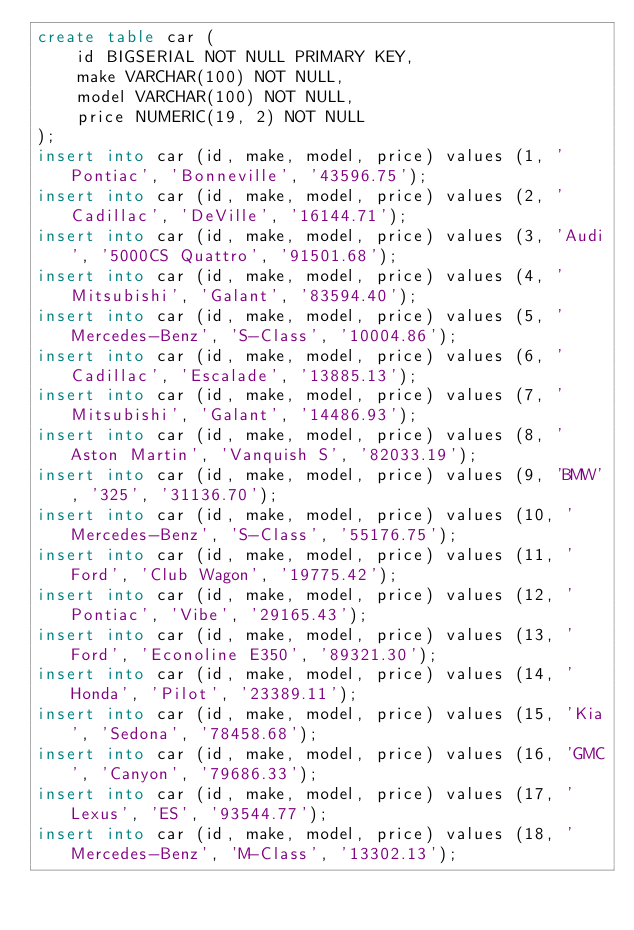Convert code to text. <code><loc_0><loc_0><loc_500><loc_500><_SQL_>create table car (
	id BIGSERIAL NOT NULL PRIMARY KEY,
	make VARCHAR(100) NOT NULL,
	model VARCHAR(100) NOT NULL,
	price NUMERIC(19, 2) NOT NULL
);
insert into car (id, make, model, price) values (1, 'Pontiac', 'Bonneville', '43596.75');
insert into car (id, make, model, price) values (2, 'Cadillac', 'DeVille', '16144.71');
insert into car (id, make, model, price) values (3, 'Audi', '5000CS Quattro', '91501.68');
insert into car (id, make, model, price) values (4, 'Mitsubishi', 'Galant', '83594.40');
insert into car (id, make, model, price) values (5, 'Mercedes-Benz', 'S-Class', '10004.86');
insert into car (id, make, model, price) values (6, 'Cadillac', 'Escalade', '13885.13');
insert into car (id, make, model, price) values (7, 'Mitsubishi', 'Galant', '14486.93');
insert into car (id, make, model, price) values (8, 'Aston Martin', 'Vanquish S', '82033.19');
insert into car (id, make, model, price) values (9, 'BMW', '325', '31136.70');
insert into car (id, make, model, price) values (10, 'Mercedes-Benz', 'S-Class', '55176.75');
insert into car (id, make, model, price) values (11, 'Ford', 'Club Wagon', '19775.42');
insert into car (id, make, model, price) values (12, 'Pontiac', 'Vibe', '29165.43');
insert into car (id, make, model, price) values (13, 'Ford', 'Econoline E350', '89321.30');
insert into car (id, make, model, price) values (14, 'Honda', 'Pilot', '23389.11');
insert into car (id, make, model, price) values (15, 'Kia', 'Sedona', '78458.68');
insert into car (id, make, model, price) values (16, 'GMC', 'Canyon', '79686.33');
insert into car (id, make, model, price) values (17, 'Lexus', 'ES', '93544.77');
insert into car (id, make, model, price) values (18, 'Mercedes-Benz', 'M-Class', '13302.13');</code> 